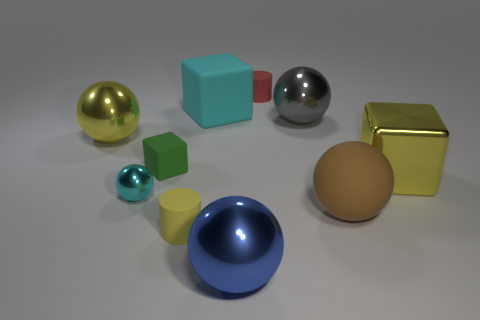Can you describe the shapes and their colors? Certainly! There are several three-dimensional shapes in this image. I see a golden sphere, a cyan cube, a silver sphere, a red cube, a teal sphere, a yellow cylinder, a blue hemisphere, and a tan ellipsoid. 